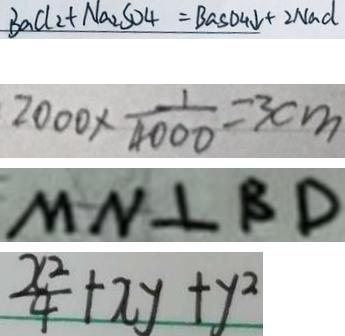<formula> <loc_0><loc_0><loc_500><loc_500>B a C l _ { 2 } + N a _ { 2 } S O _ { 4 } = B a S O _ { 4 } \downarrow + 2 N a d 
 2 0 0 0 \times \frac { 1 } { 4 0 0 0 } = 3 c m 
 M N \bot B D 
 \frac { x ^ { 2 } } { 4 } + x y + y ^ { 2 }</formula> 